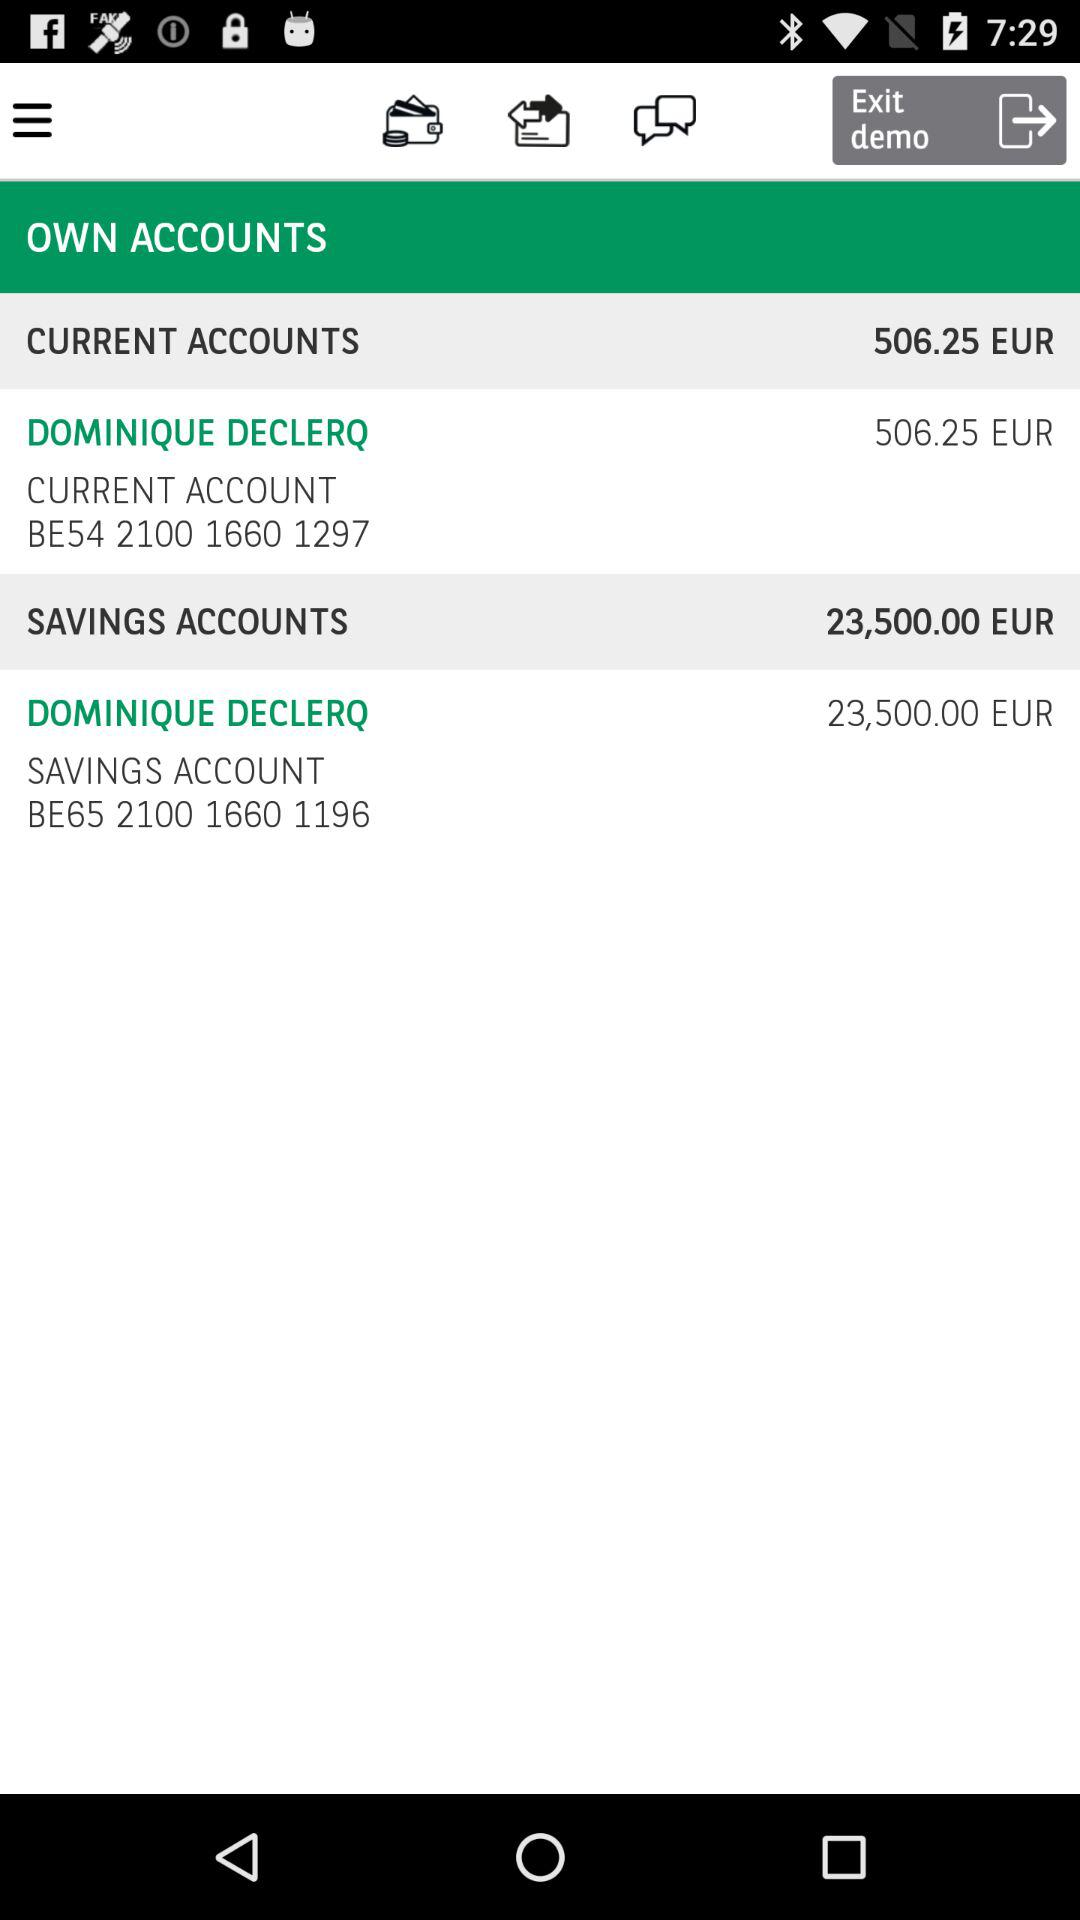How much money is in the savings account?
Answer the question using a single word or phrase. 23,500.00 EUR 